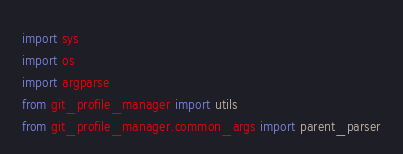Convert code to text. <code><loc_0><loc_0><loc_500><loc_500><_Python_>import sys
import os
import argparse
from git_profile_manager import utils 
from git_profile_manager.common_args import parent_parser

</code> 